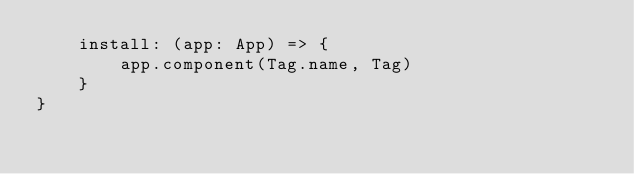<code> <loc_0><loc_0><loc_500><loc_500><_TypeScript_>    install: (app: App) => {
        app.component(Tag.name, Tag)
    }
}</code> 